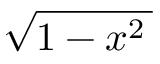Convert formula to latex. <formula><loc_0><loc_0><loc_500><loc_500>\sqrt { 1 - x ^ { 2 } \, }</formula> 